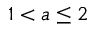Convert formula to latex. <formula><loc_0><loc_0><loc_500><loc_500>1 < a \leq 2</formula> 